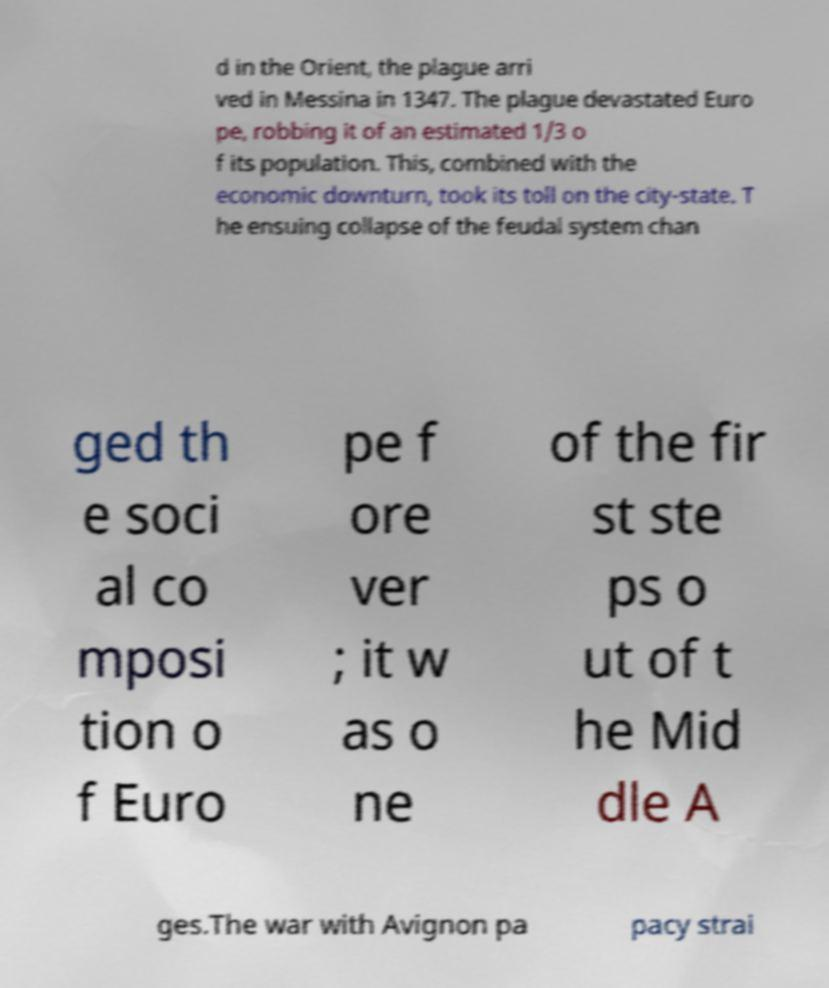Could you assist in decoding the text presented in this image and type it out clearly? d in the Orient, the plague arri ved in Messina in 1347. The plague devastated Euro pe, robbing it of an estimated 1/3 o f its population. This, combined with the economic downturn, took its toll on the city-state. T he ensuing collapse of the feudal system chan ged th e soci al co mposi tion o f Euro pe f ore ver ; it w as o ne of the fir st ste ps o ut of t he Mid dle A ges.The war with Avignon pa pacy strai 